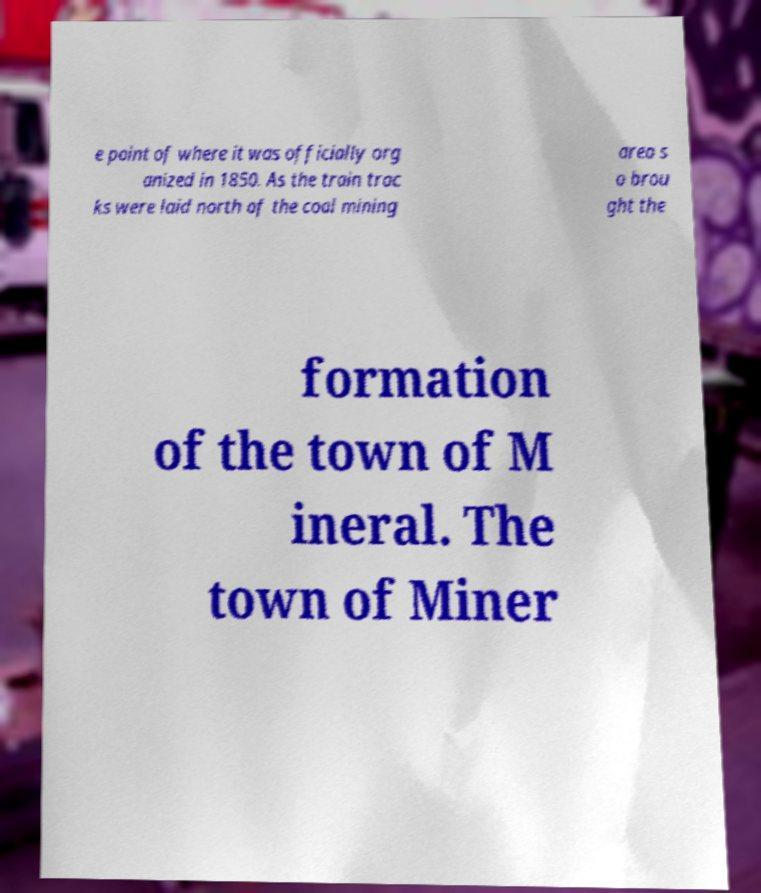For documentation purposes, I need the text within this image transcribed. Could you provide that? e point of where it was officially org anized in 1850. As the train trac ks were laid north of the coal mining area s o brou ght the formation of the town of M ineral. The town of Miner 